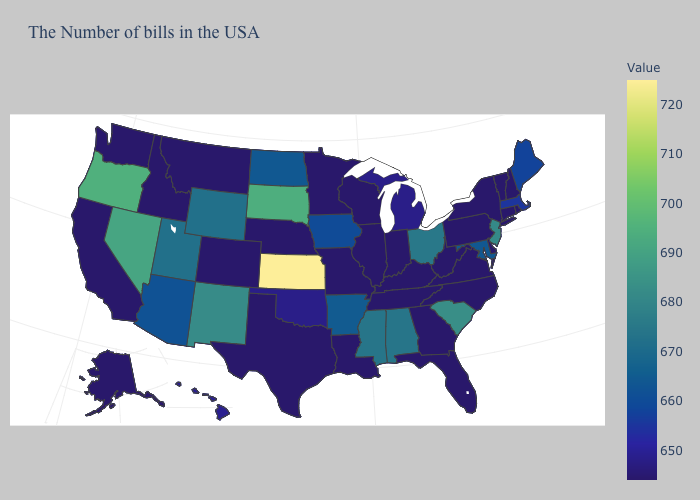Among the states that border Iowa , does Missouri have the highest value?
Quick response, please. No. Among the states that border Michigan , which have the highest value?
Concise answer only. Ohio. Does New Hampshire have a higher value than Ohio?
Short answer required. No. 